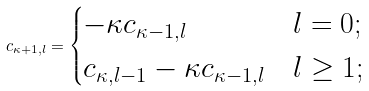Convert formula to latex. <formula><loc_0><loc_0><loc_500><loc_500>c _ { \kappa + 1 , l } = \begin{cases} - \kappa c _ { \kappa - 1 , l } & l = 0 ; \\ c _ { \kappa , l - 1 } - \kappa c _ { \kappa - 1 , l } & l \geq 1 ; \end{cases}</formula> 